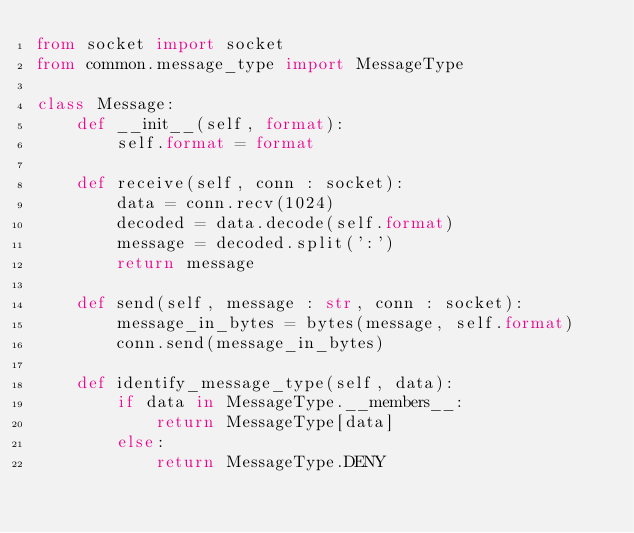Convert code to text. <code><loc_0><loc_0><loc_500><loc_500><_Python_>from socket import socket
from common.message_type import MessageType

class Message:
    def __init__(self, format):
        self.format = format

    def receive(self, conn : socket):
        data = conn.recv(1024)
        decoded = data.decode(self.format)
        message = decoded.split(':')
        return message

    def send(self, message : str, conn : socket):
        message_in_bytes = bytes(message, self.format)
        conn.send(message_in_bytes)

    def identify_message_type(self, data):
        if data in MessageType.__members__:
            return MessageType[data]
        else:
            return MessageType.DENY</code> 